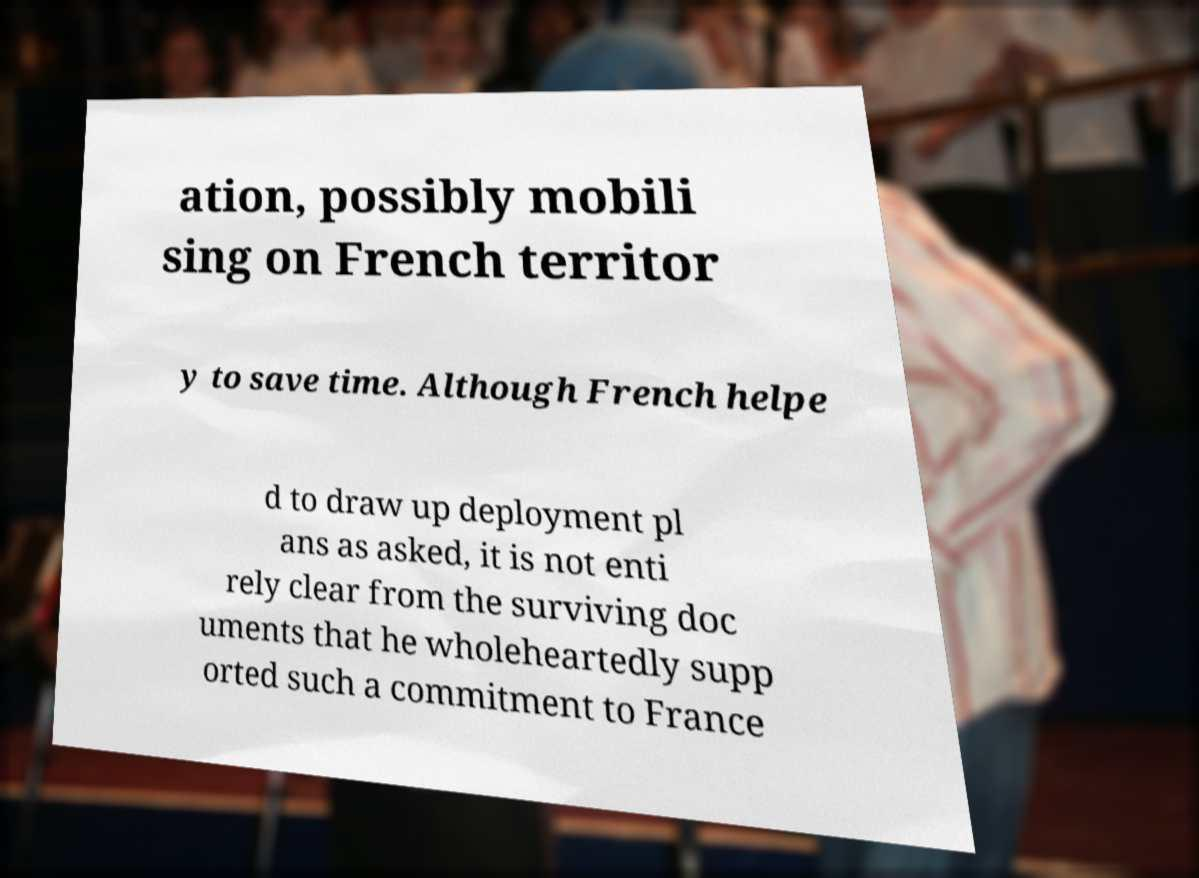Could you assist in decoding the text presented in this image and type it out clearly? ation, possibly mobili sing on French territor y to save time. Although French helpe d to draw up deployment pl ans as asked, it is not enti rely clear from the surviving doc uments that he wholeheartedly supp orted such a commitment to France 